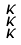<formula> <loc_0><loc_0><loc_500><loc_500>\begin{smallmatrix} \kappa \\ \kappa \\ \kappa \end{smallmatrix}</formula> 